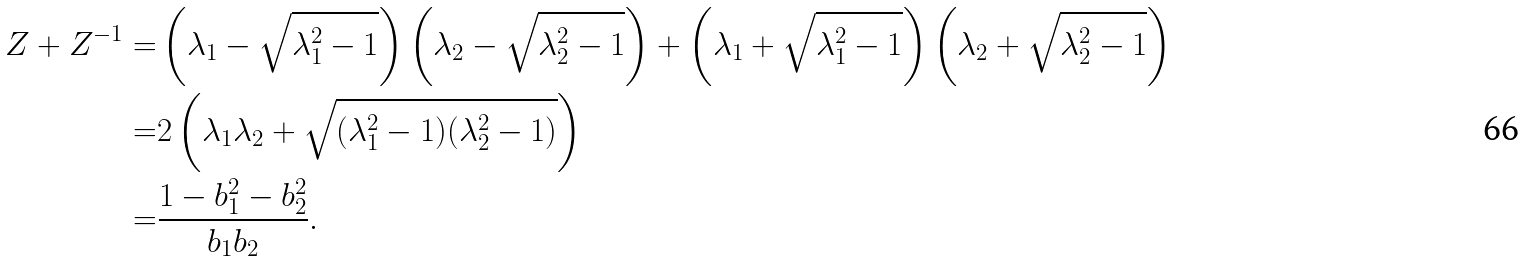Convert formula to latex. <formula><loc_0><loc_0><loc_500><loc_500>Z + Z ^ { - 1 } = & \left ( \lambda _ { 1 } - \sqrt { \lambda _ { 1 } ^ { 2 } - 1 } \right ) \left ( \lambda _ { 2 } - \sqrt { \lambda _ { 2 } ^ { 2 } - 1 } \right ) + \left ( \lambda _ { 1 } + \sqrt { \lambda _ { 1 } ^ { 2 } - 1 } \right ) \left ( \lambda _ { 2 } + \sqrt { \lambda _ { 2 } ^ { 2 } - 1 } \right ) \\ = & 2 \left ( \lambda _ { 1 } \lambda _ { 2 } + \sqrt { ( \lambda _ { 1 } ^ { 2 } - 1 ) ( \lambda _ { 2 } ^ { 2 } - 1 ) } \right ) \\ = & \frac { 1 - b _ { 1 } ^ { 2 } - b _ { 2 } ^ { 2 } } { b _ { 1 } b _ { 2 } } .</formula> 